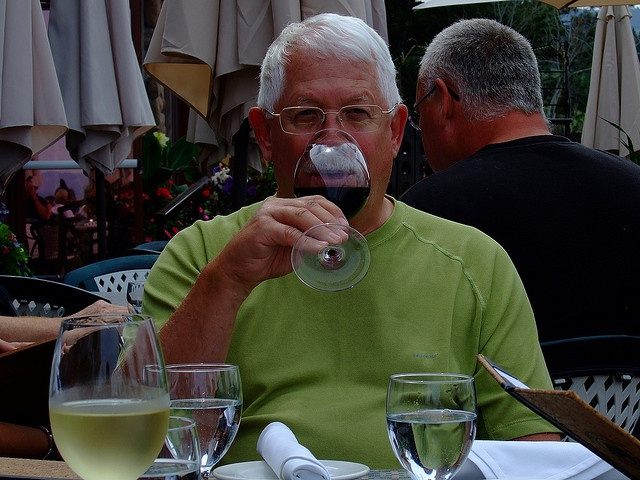Describe the objects in this image and their specific colors. I can see people in gray, darkgreen, maroon, and black tones, people in gray, black, maroon, and darkgray tones, wine glass in gray, darkgreen, black, and darkgray tones, umbrella in gray, black, and maroon tones, and umbrella in gray and black tones in this image. 